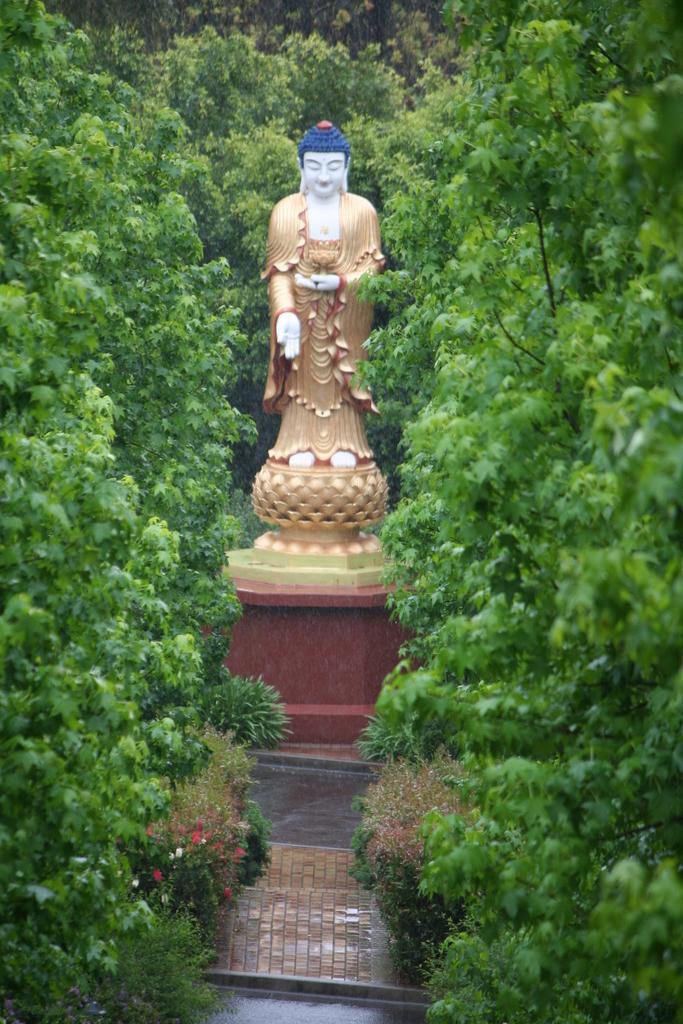How would you summarize this image in a sentence or two? In this picture there is a statue and there are trees. At the bottom there is a floor and there are flowers on the plants. 